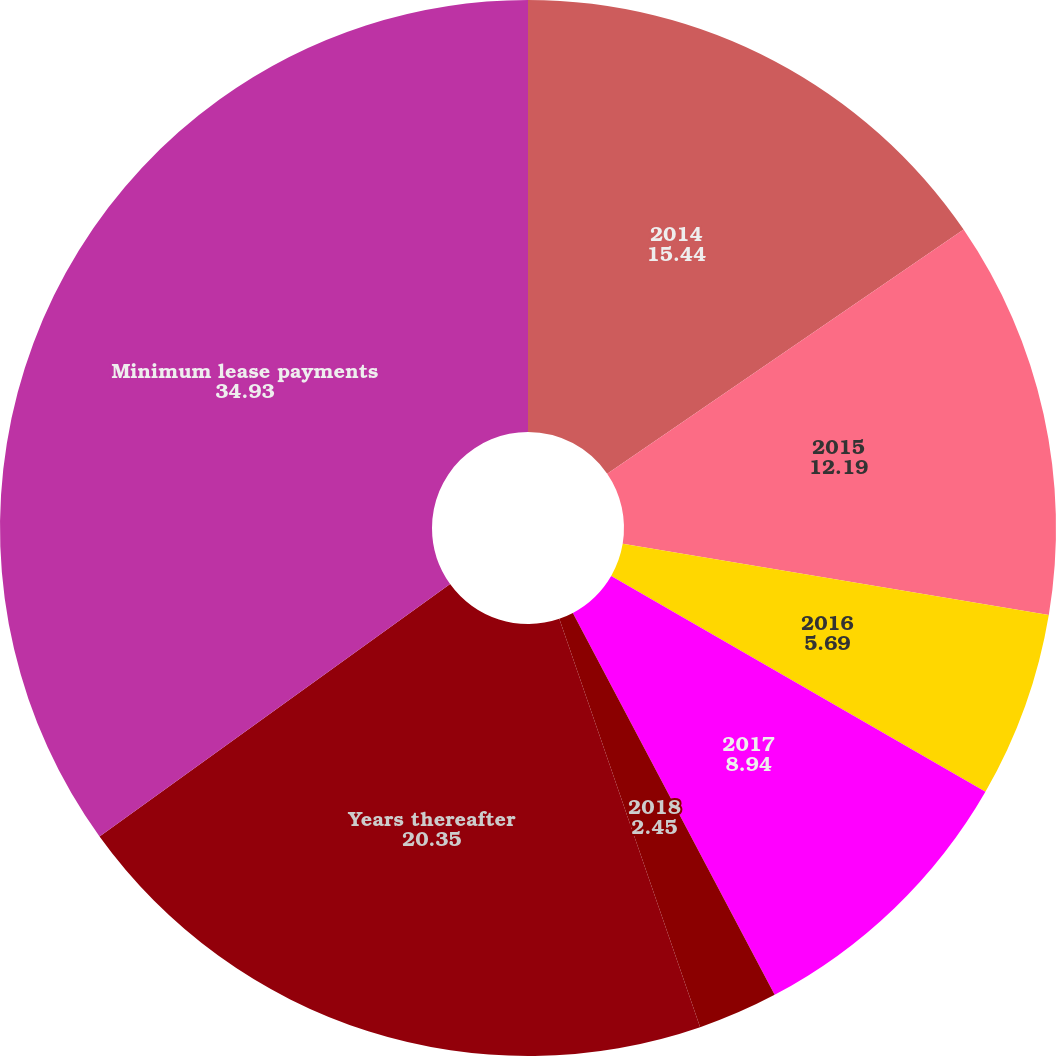Convert chart to OTSL. <chart><loc_0><loc_0><loc_500><loc_500><pie_chart><fcel>2014<fcel>2015<fcel>2016<fcel>2017<fcel>2018<fcel>Years thereafter<fcel>Minimum lease payments<nl><fcel>15.44%<fcel>12.19%<fcel>5.69%<fcel>8.94%<fcel>2.45%<fcel>20.35%<fcel>34.93%<nl></chart> 